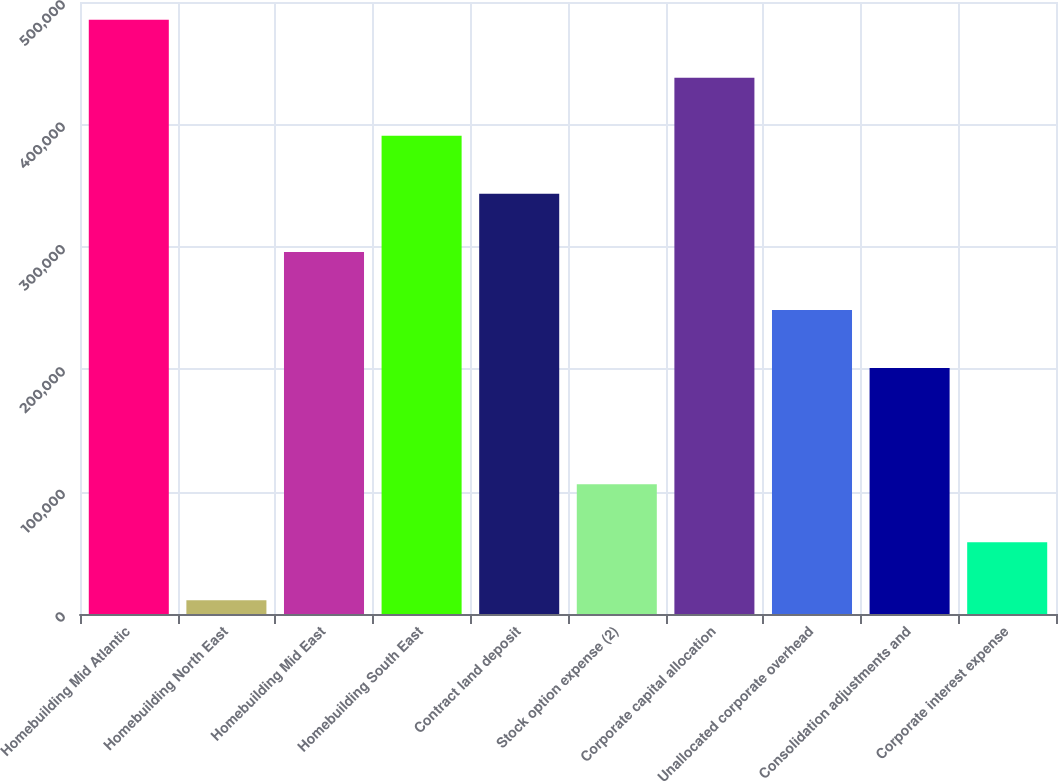Convert chart. <chart><loc_0><loc_0><loc_500><loc_500><bar_chart><fcel>Homebuilding Mid Atlantic<fcel>Homebuilding North East<fcel>Homebuilding Mid East<fcel>Homebuilding South East<fcel>Contract land deposit<fcel>Stock option expense (2)<fcel>Corporate capital allocation<fcel>Unallocated corporate overhead<fcel>Consolidation adjustments and<fcel>Corporate interest expense<nl><fcel>485576<fcel>11176<fcel>295816<fcel>390696<fcel>343256<fcel>106056<fcel>438136<fcel>248376<fcel>200936<fcel>58616<nl></chart> 